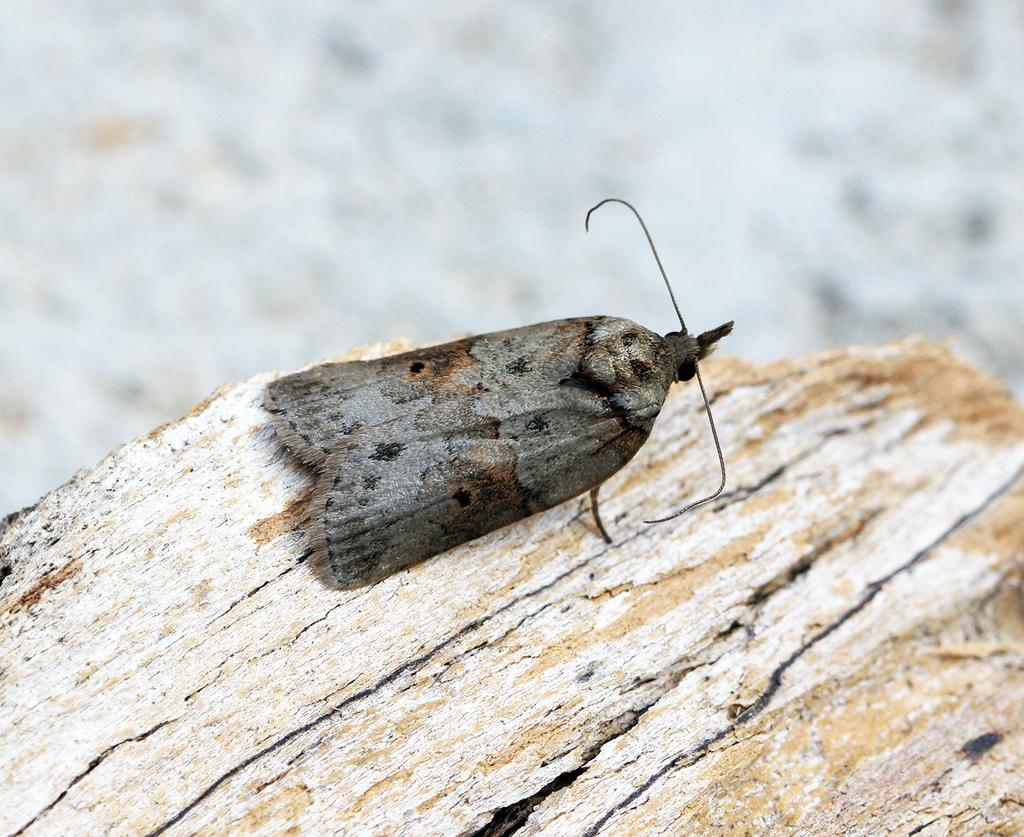What type of creature can be seen in the image? There is an insect in the image. What is the insect resting on? The insect is on a wooden object. Where is the insect located in the image? The insect is located in the bottom of the image. How many lizards can be seen entering the door in the image? There are no lizards or doors present in the image; it features an insect on a wooden object. 